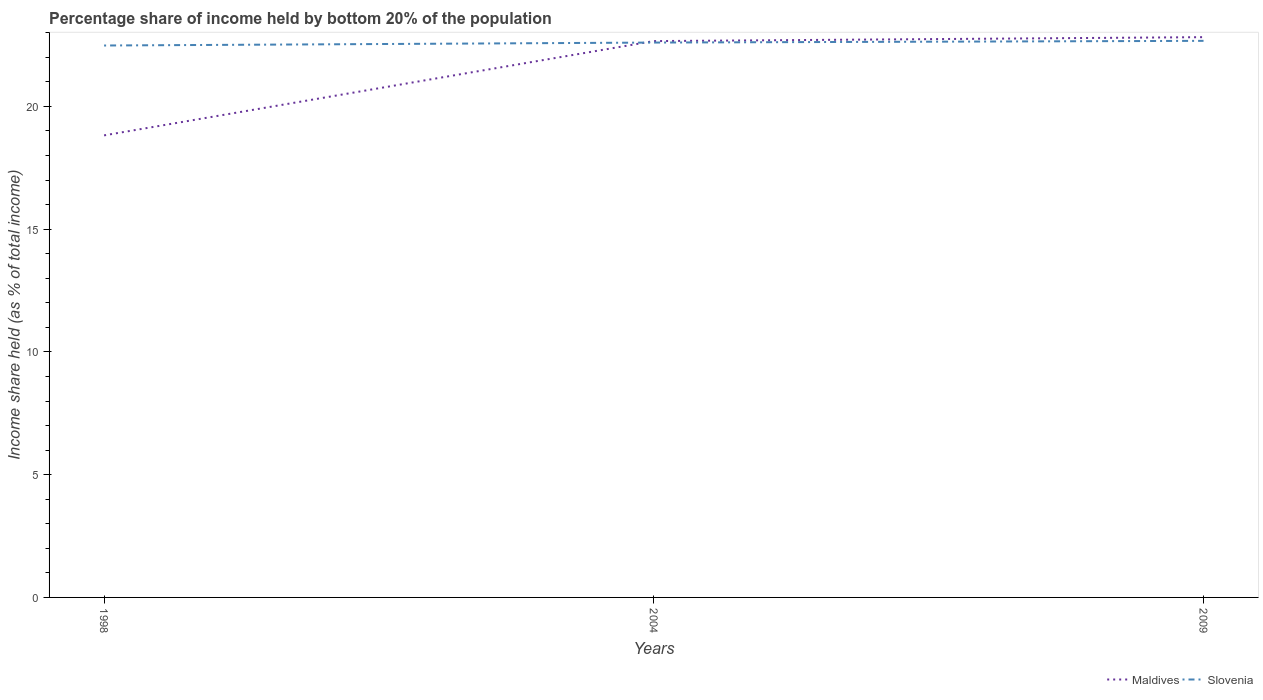How many different coloured lines are there?
Provide a short and direct response. 2. Does the line corresponding to Maldives intersect with the line corresponding to Slovenia?
Your response must be concise. Yes. Across all years, what is the maximum share of income held by bottom 20% of the population in Maldives?
Your answer should be compact. 18.82. In which year was the share of income held by bottom 20% of the population in Maldives maximum?
Keep it short and to the point. 1998. What is the total share of income held by bottom 20% of the population in Maldives in the graph?
Make the answer very short. -3.84. What is the difference between the highest and the second highest share of income held by bottom 20% of the population in Slovenia?
Give a very brief answer. 0.19. Is the share of income held by bottom 20% of the population in Slovenia strictly greater than the share of income held by bottom 20% of the population in Maldives over the years?
Offer a very short reply. No. How many years are there in the graph?
Give a very brief answer. 3. What is the difference between two consecutive major ticks on the Y-axis?
Offer a very short reply. 5. What is the title of the graph?
Offer a very short reply. Percentage share of income held by bottom 20% of the population. What is the label or title of the X-axis?
Your answer should be compact. Years. What is the label or title of the Y-axis?
Keep it short and to the point. Income share held (as % of total income). What is the Income share held (as % of total income) in Maldives in 1998?
Keep it short and to the point. 18.82. What is the Income share held (as % of total income) of Slovenia in 1998?
Your answer should be compact. 22.48. What is the Income share held (as % of total income) of Maldives in 2004?
Make the answer very short. 22.66. What is the Income share held (as % of total income) in Slovenia in 2004?
Give a very brief answer. 22.6. What is the Income share held (as % of total income) of Maldives in 2009?
Offer a terse response. 22.82. What is the Income share held (as % of total income) in Slovenia in 2009?
Your answer should be compact. 22.67. Across all years, what is the maximum Income share held (as % of total income) of Maldives?
Offer a terse response. 22.82. Across all years, what is the maximum Income share held (as % of total income) of Slovenia?
Your response must be concise. 22.67. Across all years, what is the minimum Income share held (as % of total income) in Maldives?
Offer a very short reply. 18.82. Across all years, what is the minimum Income share held (as % of total income) in Slovenia?
Your response must be concise. 22.48. What is the total Income share held (as % of total income) of Maldives in the graph?
Give a very brief answer. 64.3. What is the total Income share held (as % of total income) of Slovenia in the graph?
Your answer should be very brief. 67.75. What is the difference between the Income share held (as % of total income) in Maldives in 1998 and that in 2004?
Give a very brief answer. -3.84. What is the difference between the Income share held (as % of total income) of Slovenia in 1998 and that in 2004?
Provide a succinct answer. -0.12. What is the difference between the Income share held (as % of total income) of Slovenia in 1998 and that in 2009?
Ensure brevity in your answer.  -0.19. What is the difference between the Income share held (as % of total income) of Maldives in 2004 and that in 2009?
Your answer should be very brief. -0.16. What is the difference between the Income share held (as % of total income) in Slovenia in 2004 and that in 2009?
Provide a short and direct response. -0.07. What is the difference between the Income share held (as % of total income) of Maldives in 1998 and the Income share held (as % of total income) of Slovenia in 2004?
Your response must be concise. -3.78. What is the difference between the Income share held (as % of total income) of Maldives in 1998 and the Income share held (as % of total income) of Slovenia in 2009?
Your answer should be very brief. -3.85. What is the difference between the Income share held (as % of total income) in Maldives in 2004 and the Income share held (as % of total income) in Slovenia in 2009?
Ensure brevity in your answer.  -0.01. What is the average Income share held (as % of total income) of Maldives per year?
Give a very brief answer. 21.43. What is the average Income share held (as % of total income) of Slovenia per year?
Ensure brevity in your answer.  22.58. In the year 1998, what is the difference between the Income share held (as % of total income) in Maldives and Income share held (as % of total income) in Slovenia?
Offer a very short reply. -3.66. In the year 2004, what is the difference between the Income share held (as % of total income) of Maldives and Income share held (as % of total income) of Slovenia?
Give a very brief answer. 0.06. In the year 2009, what is the difference between the Income share held (as % of total income) in Maldives and Income share held (as % of total income) in Slovenia?
Provide a succinct answer. 0.15. What is the ratio of the Income share held (as % of total income) of Maldives in 1998 to that in 2004?
Offer a very short reply. 0.83. What is the ratio of the Income share held (as % of total income) of Slovenia in 1998 to that in 2004?
Provide a succinct answer. 0.99. What is the ratio of the Income share held (as % of total income) in Maldives in 1998 to that in 2009?
Your answer should be compact. 0.82. What is the ratio of the Income share held (as % of total income) in Slovenia in 1998 to that in 2009?
Make the answer very short. 0.99. What is the ratio of the Income share held (as % of total income) of Maldives in 2004 to that in 2009?
Provide a succinct answer. 0.99. What is the ratio of the Income share held (as % of total income) in Slovenia in 2004 to that in 2009?
Make the answer very short. 1. What is the difference between the highest and the second highest Income share held (as % of total income) of Maldives?
Provide a short and direct response. 0.16. What is the difference between the highest and the second highest Income share held (as % of total income) of Slovenia?
Offer a very short reply. 0.07. What is the difference between the highest and the lowest Income share held (as % of total income) in Maldives?
Provide a short and direct response. 4. What is the difference between the highest and the lowest Income share held (as % of total income) in Slovenia?
Your answer should be compact. 0.19. 